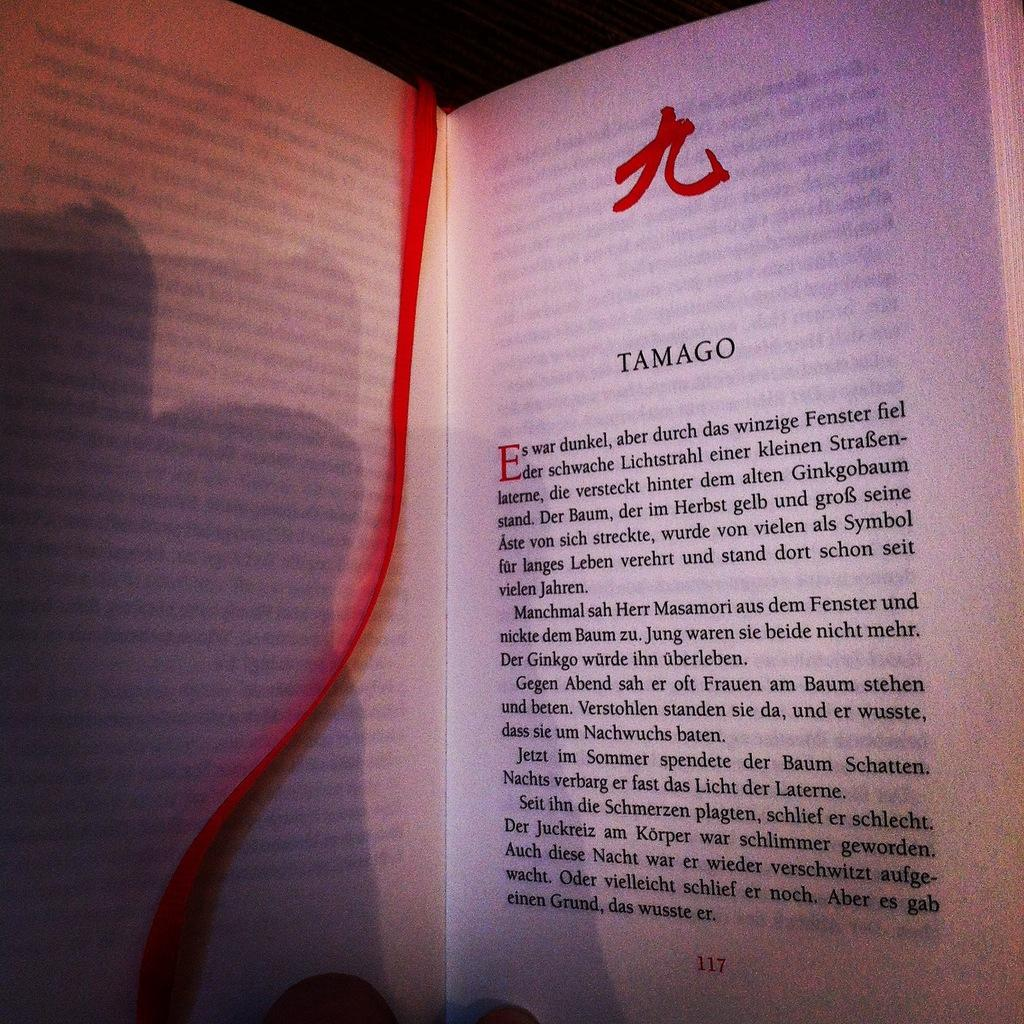Provide a one-sentence caption for the provided image. A book is open to page 117 and has a red ribbon bookmark. 